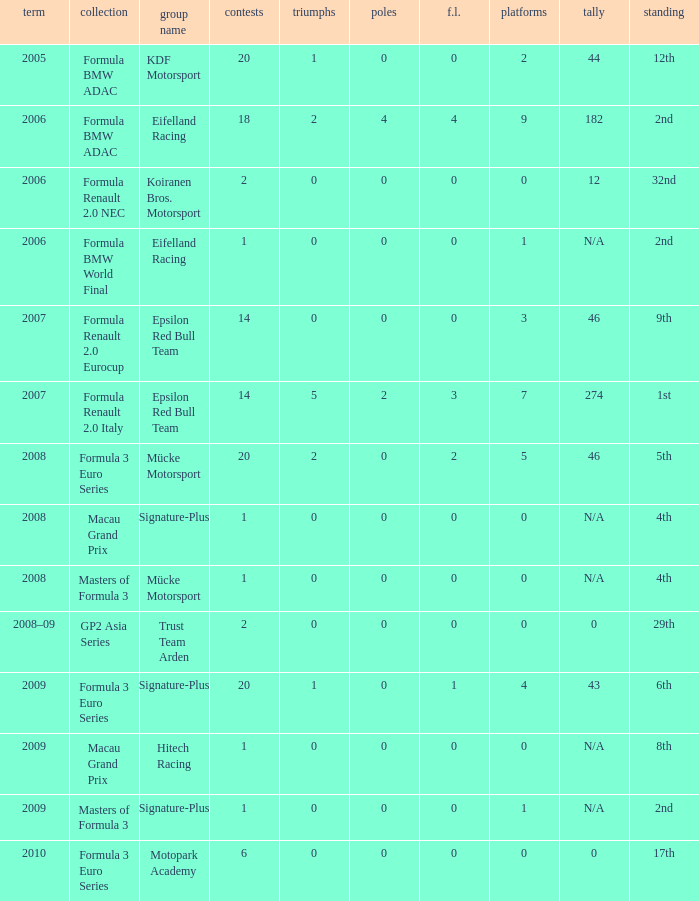What is the race in the 8th position? 1.0. 